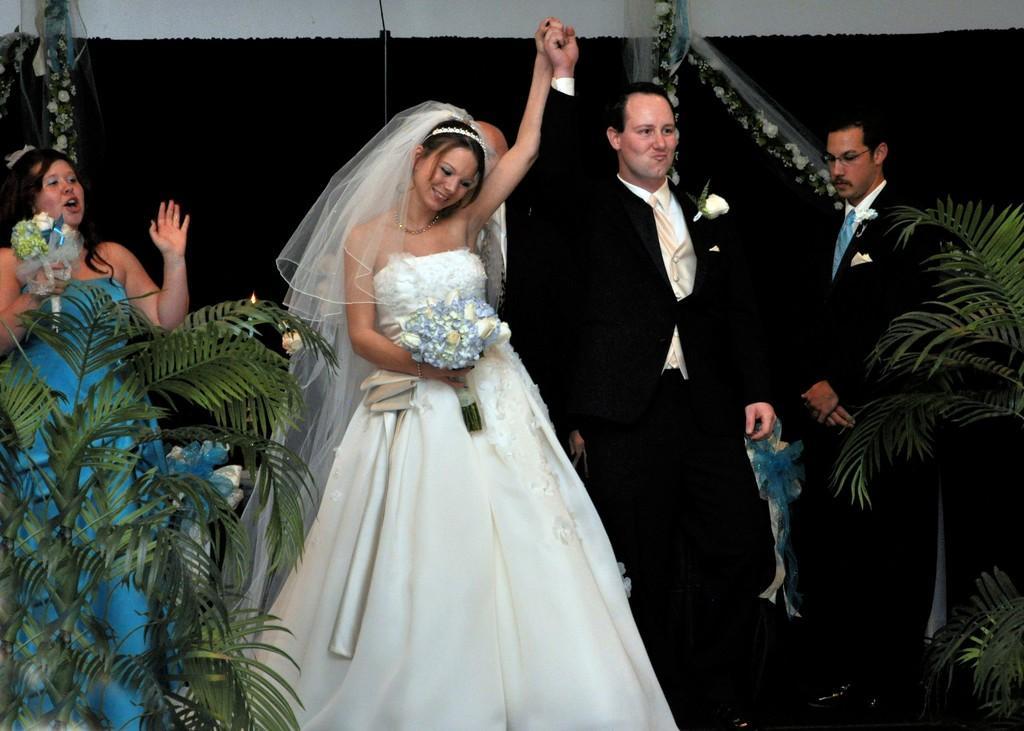In one or two sentences, can you explain what this image depicts? This picture describes about group of people, in the middle of the image we can see a woman, she wore a white color dress and she is holding a bouquet, beside to her we can see few plants. 